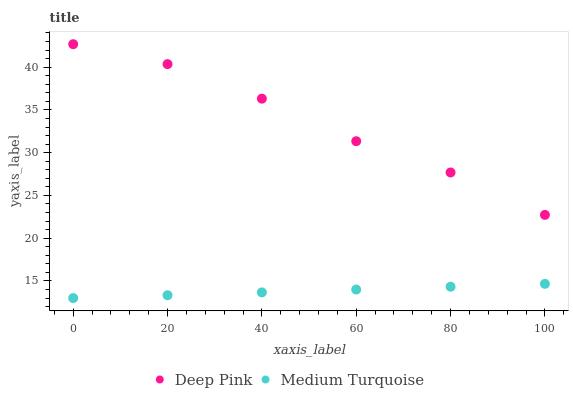Does Medium Turquoise have the minimum area under the curve?
Answer yes or no. Yes. Does Deep Pink have the maximum area under the curve?
Answer yes or no. Yes. Does Medium Turquoise have the maximum area under the curve?
Answer yes or no. No. Is Medium Turquoise the smoothest?
Answer yes or no. Yes. Is Deep Pink the roughest?
Answer yes or no. Yes. Is Medium Turquoise the roughest?
Answer yes or no. No. Does Medium Turquoise have the lowest value?
Answer yes or no. Yes. Does Deep Pink have the highest value?
Answer yes or no. Yes. Does Medium Turquoise have the highest value?
Answer yes or no. No. Is Medium Turquoise less than Deep Pink?
Answer yes or no. Yes. Is Deep Pink greater than Medium Turquoise?
Answer yes or no. Yes. Does Medium Turquoise intersect Deep Pink?
Answer yes or no. No. 